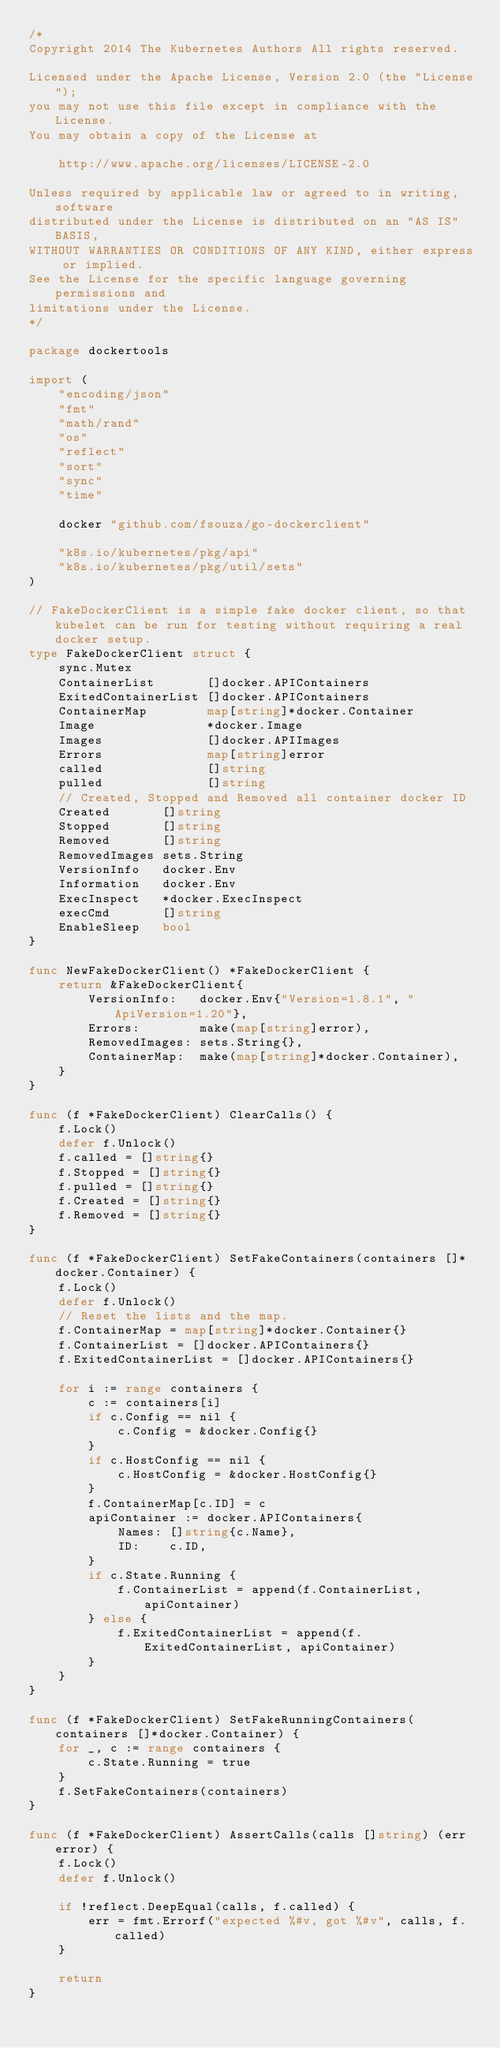<code> <loc_0><loc_0><loc_500><loc_500><_Go_>/*
Copyright 2014 The Kubernetes Authors All rights reserved.

Licensed under the Apache License, Version 2.0 (the "License");
you may not use this file except in compliance with the License.
You may obtain a copy of the License at

    http://www.apache.org/licenses/LICENSE-2.0

Unless required by applicable law or agreed to in writing, software
distributed under the License is distributed on an "AS IS" BASIS,
WITHOUT WARRANTIES OR CONDITIONS OF ANY KIND, either express or implied.
See the License for the specific language governing permissions and
limitations under the License.
*/

package dockertools

import (
	"encoding/json"
	"fmt"
	"math/rand"
	"os"
	"reflect"
	"sort"
	"sync"
	"time"

	docker "github.com/fsouza/go-dockerclient"

	"k8s.io/kubernetes/pkg/api"
	"k8s.io/kubernetes/pkg/util/sets"
)

// FakeDockerClient is a simple fake docker client, so that kubelet can be run for testing without requiring a real docker setup.
type FakeDockerClient struct {
	sync.Mutex
	ContainerList       []docker.APIContainers
	ExitedContainerList []docker.APIContainers
	ContainerMap        map[string]*docker.Container
	Image               *docker.Image
	Images              []docker.APIImages
	Errors              map[string]error
	called              []string
	pulled              []string
	// Created, Stopped and Removed all container docker ID
	Created       []string
	Stopped       []string
	Removed       []string
	RemovedImages sets.String
	VersionInfo   docker.Env
	Information   docker.Env
	ExecInspect   *docker.ExecInspect
	execCmd       []string
	EnableSleep   bool
}

func NewFakeDockerClient() *FakeDockerClient {
	return &FakeDockerClient{
		VersionInfo:   docker.Env{"Version=1.8.1", "ApiVersion=1.20"},
		Errors:        make(map[string]error),
		RemovedImages: sets.String{},
		ContainerMap:  make(map[string]*docker.Container),
	}
}

func (f *FakeDockerClient) ClearCalls() {
	f.Lock()
	defer f.Unlock()
	f.called = []string{}
	f.Stopped = []string{}
	f.pulled = []string{}
	f.Created = []string{}
	f.Removed = []string{}
}

func (f *FakeDockerClient) SetFakeContainers(containers []*docker.Container) {
	f.Lock()
	defer f.Unlock()
	// Reset the lists and the map.
	f.ContainerMap = map[string]*docker.Container{}
	f.ContainerList = []docker.APIContainers{}
	f.ExitedContainerList = []docker.APIContainers{}

	for i := range containers {
		c := containers[i]
		if c.Config == nil {
			c.Config = &docker.Config{}
		}
		if c.HostConfig == nil {
			c.HostConfig = &docker.HostConfig{}
		}
		f.ContainerMap[c.ID] = c
		apiContainer := docker.APIContainers{
			Names: []string{c.Name},
			ID:    c.ID,
		}
		if c.State.Running {
			f.ContainerList = append(f.ContainerList, apiContainer)
		} else {
			f.ExitedContainerList = append(f.ExitedContainerList, apiContainer)
		}
	}
}

func (f *FakeDockerClient) SetFakeRunningContainers(containers []*docker.Container) {
	for _, c := range containers {
		c.State.Running = true
	}
	f.SetFakeContainers(containers)
}

func (f *FakeDockerClient) AssertCalls(calls []string) (err error) {
	f.Lock()
	defer f.Unlock()

	if !reflect.DeepEqual(calls, f.called) {
		err = fmt.Errorf("expected %#v, got %#v", calls, f.called)
	}

	return
}
</code> 